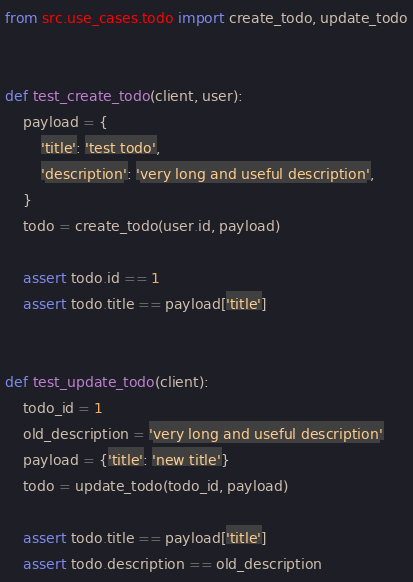<code> <loc_0><loc_0><loc_500><loc_500><_Python_>from src.use_cases.todo import create_todo, update_todo


def test_create_todo(client, user):
    payload = {
        'title': 'test todo',
        'description': 'very long and useful description',
    }
    todo = create_todo(user.id, payload)

    assert todo.id == 1
    assert todo.title == payload['title']


def test_update_todo(client):
    todo_id = 1
    old_description = 'very long and useful description'
    payload = {'title': 'new title'}
    todo = update_todo(todo_id, payload)

    assert todo.title == payload['title']
    assert todo.description == old_description
</code> 